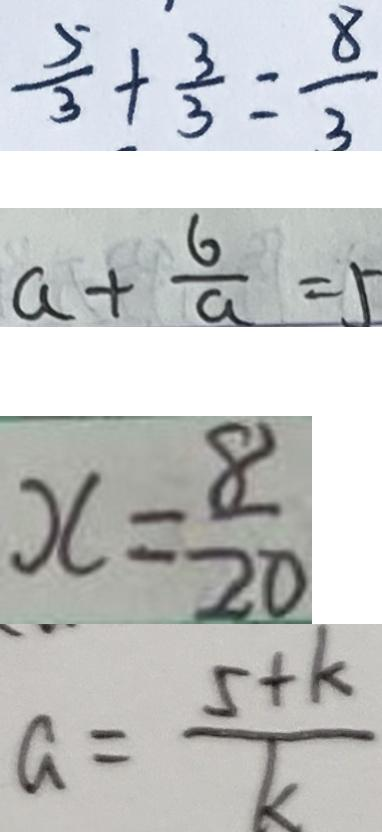<formula> <loc_0><loc_0><loc_500><loc_500>\frac { 5 } { 3 } + \frac { 3 } { 3 } = \frac { 8 } { 3 } 
 a + \frac { 6 } { a } = 5 
 x = \frac { 8 } { 2 0 } 
 a = \frac { 5 + k } { k }</formula> 